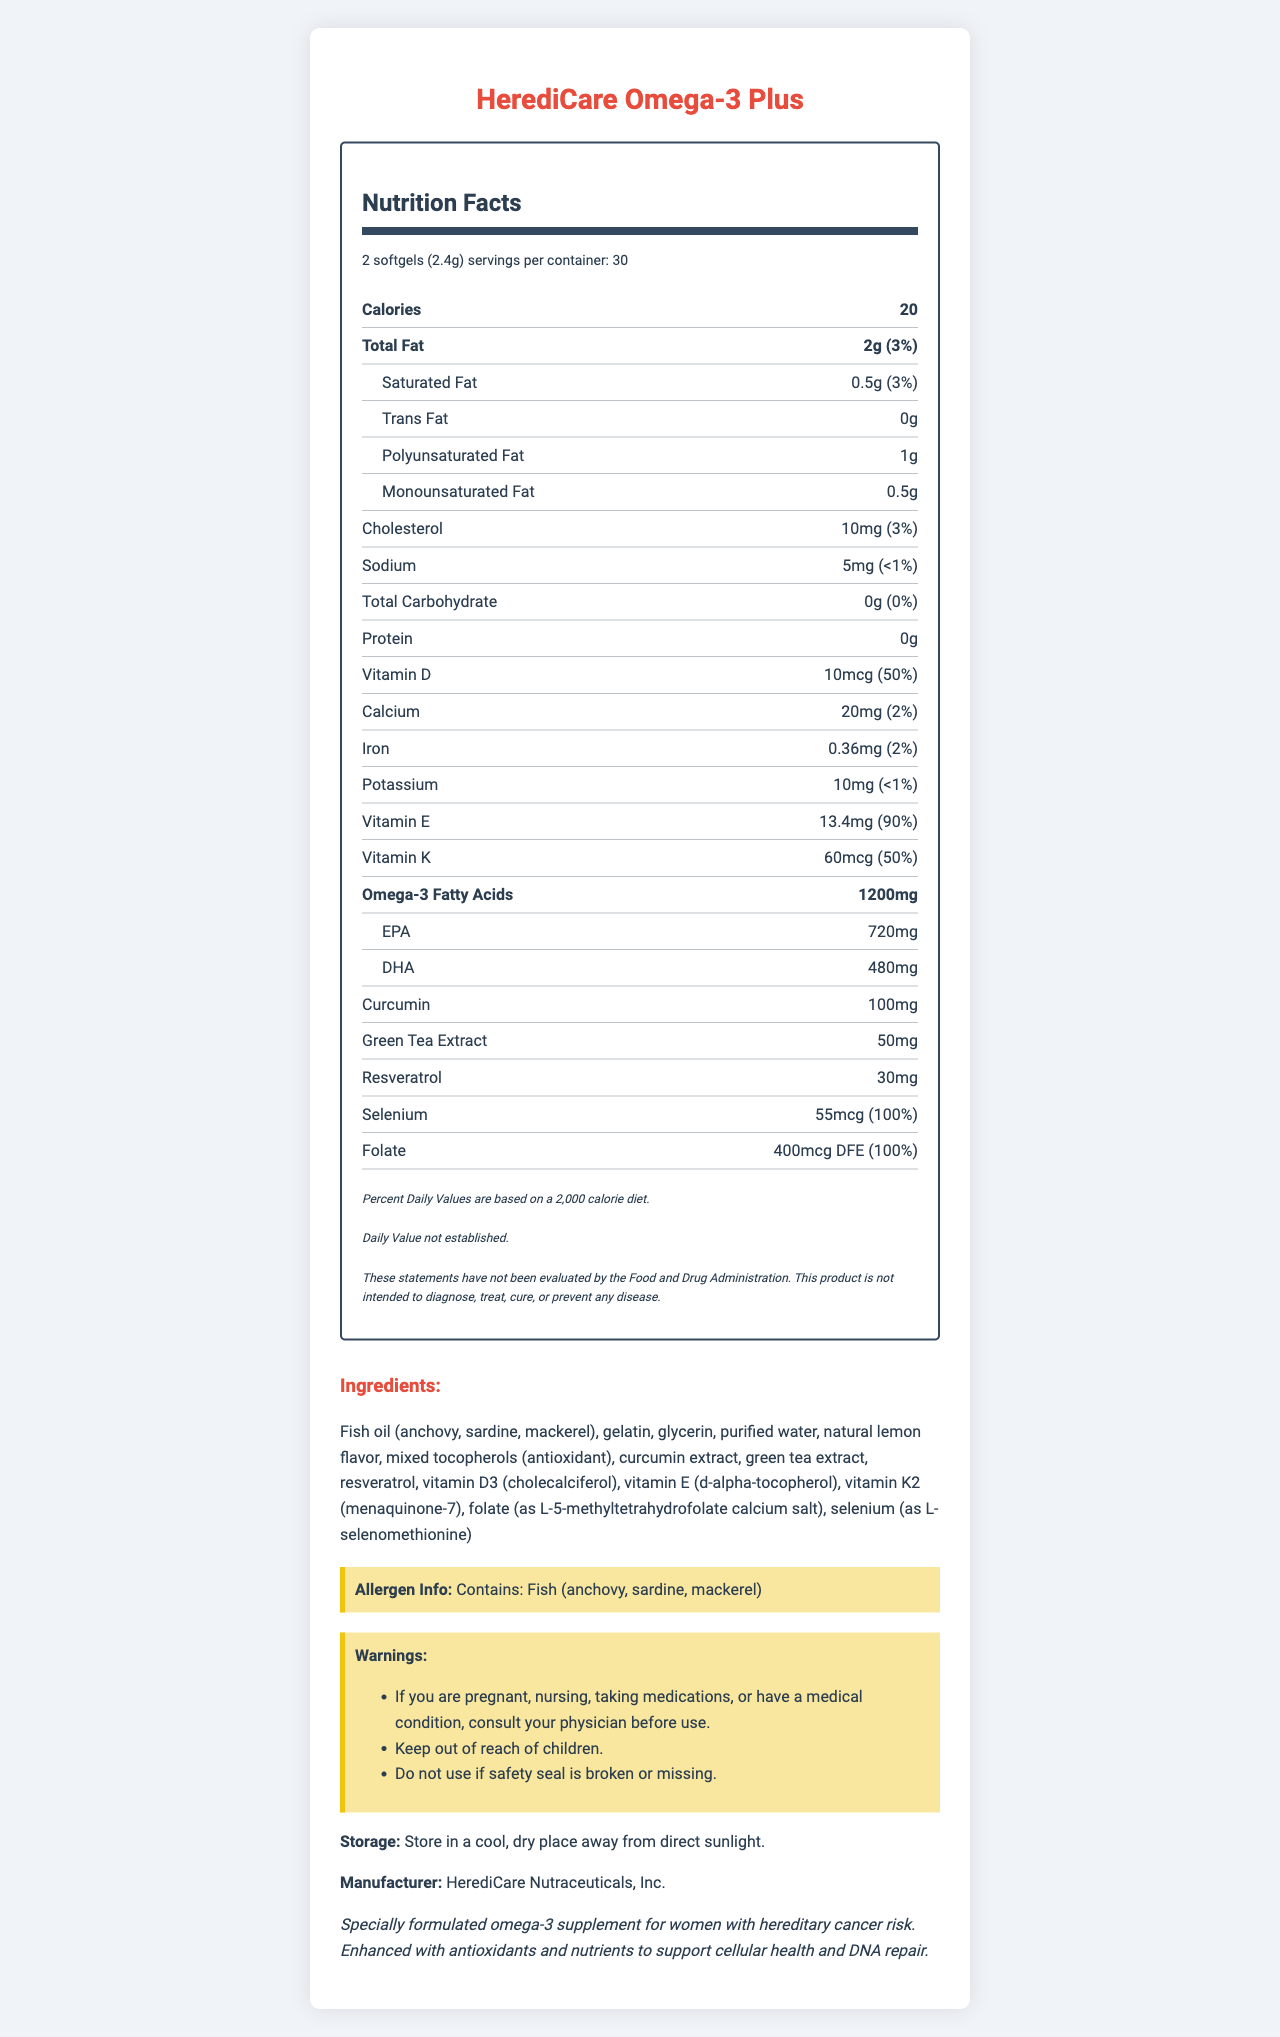what is the serving size for HerediCare Omega-3 Plus? The serving size is listed at the very top of the Nutrition Facts section.
Answer: 2 softgels (2.4g) how many servings are in one container of HerediCare Omega-3 Plus? The number of servings per container is stated under the serving size on the Nutrition Facts label.
Answer: 30 what is the total amount of calories per serving? The total amount of calories per serving is specified in the Nutrition Facts section.
Answer: 20 calories how much omega-3 fatty acids are in a serving? The amount of omega-3 fatty acids per serving is clearly listed on the Nutrition Facts label.
Answer: 1200mg how much Vitamin E is in each serving, and what percentage of the daily value (DV) does it provide? The Nutrition Facts label lists that each serving contains 13.4mg of Vitamin E, which is 90% of the daily value.
Answer: 13.4mg, 90% DV how much curcumin is in each serving of the supplement? The amount of curcumin per serving is listed in the Nutrition Facts section.
Answer: 100mg which of the following ingredients are found in the supplement? A. Fish oil B. Gelatin C. Green tea extract D. All of the above The ingredients section lists fish oil, gelatin, green tea extract, among other ingredients.
Answer: D. All of the above how much selenium is in each serving, and what is the percentage of the daily value (DV)? Selenium amounts and its daily value percentage are explicitly stated on the label.
Answer: 55mcg, 100% DV how should you store HerediCare Omega-3 Plus? The storage instructions are clearly mentioned in the document.
Answer: Store in a cool, dry place away from direct sunlight is this product free from any allergens? The label mentions it contains fish (anchovy, sardine, mackerel), so it is not free from allergens.
Answer: No True or False: HerediCare Omega-3 Plus is intended to diagnose, treat, cure, or prevent any disease. The disclaimer section states that the product is not intended to diagnose, treat, cure, or prevent any disease.
Answer: False summarize the primary purpose of the HerediCare Omega-3 Plus supplement. The product description section provides this summary, specifying its formulation and intended purpose.
Answer: Specially formulated omega-3 supplement for women with hereditary cancer risk. Enhanced with antioxidants and nutrients to support cellular health and DNA repair. is the green tea extract amount provided safe to consume? The document lists the green tea extract amount, but without further context on safety or relevant consumption guidelines, the safety cannot be assessed.
Answer: Cannot be determined 